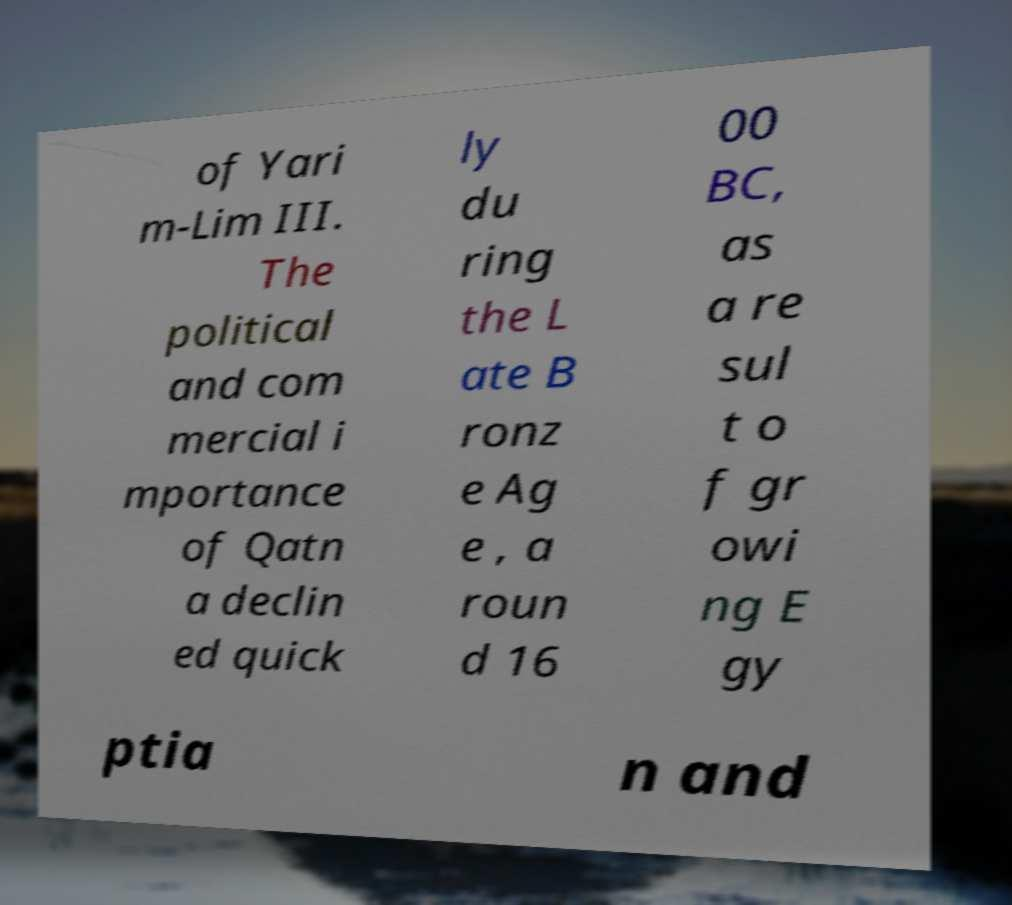Can you accurately transcribe the text from the provided image for me? of Yari m-Lim III. The political and com mercial i mportance of Qatn a declin ed quick ly du ring the L ate B ronz e Ag e , a roun d 16 00 BC, as a re sul t o f gr owi ng E gy ptia n and 